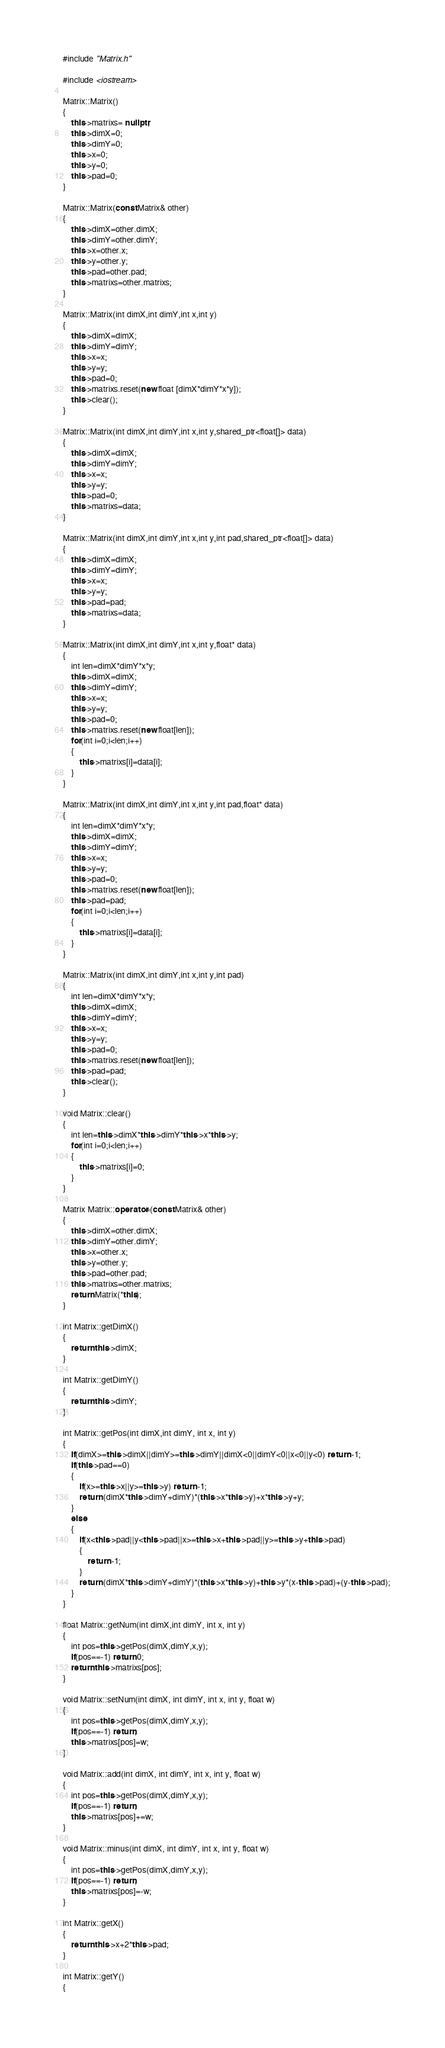Convert code to text. <code><loc_0><loc_0><loc_500><loc_500><_C++_>#include "Matrix.h"

#include <iostream>

Matrix::Matrix()
{
    this->matrixs= nullptr;
    this->dimX=0;
    this->dimY=0;
    this->x=0;
    this->y=0;
    this->pad=0;
}

Matrix::Matrix(const Matrix& other)
{
    this->dimX=other.dimX;
    this->dimY=other.dimY;
    this->x=other.x;
    this->y=other.y;
    this->pad=other.pad;
    this->matrixs=other.matrixs;
}

Matrix::Matrix(int dimX,int dimY,int x,int y)
{
    this->dimX=dimX;
    this->dimY=dimY;
    this->x=x;
    this->y=y;
    this->pad=0;
    this->matrixs.reset(new float [dimX*dimY*x*y]);
    this->clear();
}

Matrix::Matrix(int dimX,int dimY,int x,int y,shared_ptr<float[]> data)
{
    this->dimX=dimX;
    this->dimY=dimY;
    this->x=x;
    this->y=y;
    this->pad=0;
    this->matrixs=data;
}

Matrix::Matrix(int dimX,int dimY,int x,int y,int pad,shared_ptr<float[]> data)
{
    this->dimX=dimX;
    this->dimY=dimY;
    this->x=x;
    this->y=y;
    this->pad=pad;
    this->matrixs=data;
}

Matrix::Matrix(int dimX,int dimY,int x,int y,float* data)
{
    int len=dimX*dimY*x*y;
    this->dimX=dimX;
    this->dimY=dimY;
    this->x=x;
    this->y=y;
    this->pad=0;
    this->matrixs.reset(new float[len]);
    for(int i=0;i<len;i++)
    {
        this->matrixs[i]=data[i];
    }
}

Matrix::Matrix(int dimX,int dimY,int x,int y,int pad,float* data)
{
    int len=dimX*dimY*x*y;
    this->dimX=dimX;
    this->dimY=dimY;
    this->x=x;
    this->y=y;
    this->pad=0;
    this->matrixs.reset(new float[len]);
    this->pad=pad;
    for(int i=0;i<len;i++)
    {
        this->matrixs[i]=data[i];
    }
}

Matrix::Matrix(int dimX,int dimY,int x,int y,int pad)
{
    int len=dimX*dimY*x*y;
    this->dimX=dimX;
    this->dimY=dimY;
    this->x=x;
    this->y=y;
    this->pad=0;
    this->matrixs.reset(new float[len]);
    this->pad=pad;
    this->clear();
}

void Matrix::clear()
{
    int len=this->dimX*this->dimY*this->x*this->y;
    for(int i=0;i<len;i++)
    {
        this->matrixs[i]=0;
    }
}

Matrix Matrix::operator=(const Matrix& other)
{
    this->dimX=other.dimX;
    this->dimY=other.dimY;
    this->x=other.x;
    this->y=other.y;
    this->pad=other.pad;
    this->matrixs=other.matrixs;
    return Matrix(*this);
}

int Matrix::getDimX()
{
    return this->dimX;
}

int Matrix::getDimY()
{
    return this->dimY;
}

int Matrix::getPos(int dimX,int dimY, int x, int y)
{
    if(dimX>=this->dimX||dimY>=this->dimY||dimX<0||dimY<0||x<0||y<0) return -1;
    if(this->pad==0)
    {
        if(x>=this->x||y>=this->y) return -1;
        return (dimX*this->dimY+dimY)*(this->x*this->y)+x*this->y+y;
    }
    else
    {
        if(x<this->pad||y<this->pad||x>=this->x+this->pad||y>=this->y+this->pad)
        {
            return -1;
        }
        return (dimX*this->dimY+dimY)*(this->x*this->y)+this->y*(x-this->pad)+(y-this->pad);
    }
}

float Matrix::getNum(int dimX,int dimY, int x, int y)
{
    int pos=this->getPos(dimX,dimY,x,y);
    if(pos==-1) return 0;
    return this->matrixs[pos];
}

void Matrix::setNum(int dimX, int dimY, int x, int y, float w)
{
    int pos=this->getPos(dimX,dimY,x,y);
    if(pos==-1) return;
    this->matrixs[pos]=w;
}

void Matrix::add(int dimX, int dimY, int x, int y, float w)
{
    int pos=this->getPos(dimX,dimY,x,y);
    if(pos==-1) return;
    this->matrixs[pos]+=w;
}

void Matrix::minus(int dimX, int dimY, int x, int y, float w)
{
    int pos=this->getPos(dimX,dimY,x,y);
    if(pos==-1) return;
    this->matrixs[pos]=-w;
}

int Matrix::getX()
{
    return this->x+2*this->pad;
}

int Matrix::getY()
{</code> 